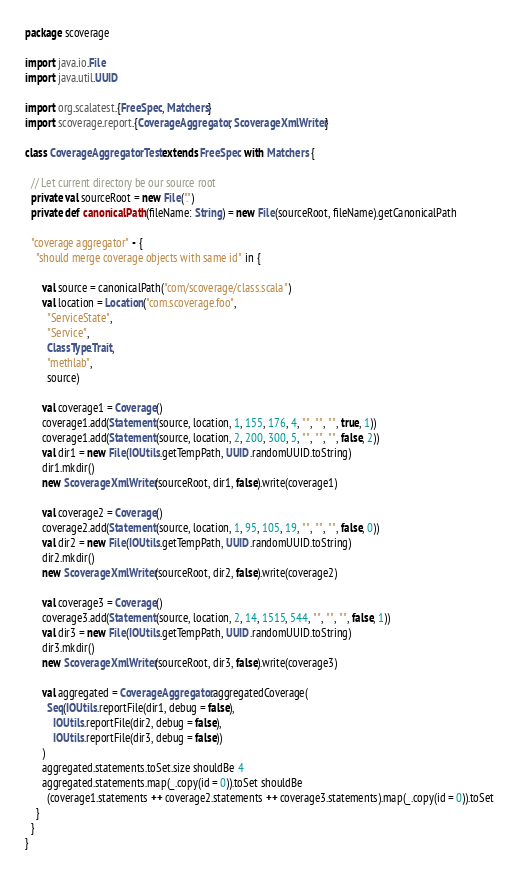Convert code to text. <code><loc_0><loc_0><loc_500><loc_500><_Scala_>package scoverage

import java.io.File
import java.util.UUID

import org.scalatest.{FreeSpec, Matchers}
import scoverage.report.{CoverageAggregator, ScoverageXmlWriter}

class CoverageAggregatorTest extends FreeSpec with Matchers {

  // Let current directory be our source root
  private val sourceRoot = new File(".")
  private def canonicalPath(fileName: String) = new File(sourceRoot, fileName).getCanonicalPath

  "coverage aggregator" - {
    "should merge coverage objects with same id" in {

      val source = canonicalPath("com/scoverage/class.scala")
      val location = Location("com.scoverage.foo",
        "ServiceState",
        "Service",
        ClassType.Trait,
        "methlab",
        source)

      val coverage1 = Coverage()
      coverage1.add(Statement(source, location, 1, 155, 176, 4, "", "", "", true, 1))
      coverage1.add(Statement(source, location, 2, 200, 300, 5, "", "", "", false, 2))
      val dir1 = new File(IOUtils.getTempPath, UUID.randomUUID.toString)
      dir1.mkdir()
      new ScoverageXmlWriter(sourceRoot, dir1, false).write(coverage1)

      val coverage2 = Coverage()
      coverage2.add(Statement(source, location, 1, 95, 105, 19, "", "", "", false, 0))
      val dir2 = new File(IOUtils.getTempPath, UUID.randomUUID.toString)
      dir2.mkdir()
      new ScoverageXmlWriter(sourceRoot, dir2, false).write(coverage2)

      val coverage3 = Coverage()
      coverage3.add(Statement(source, location, 2, 14, 1515, 544, "", "", "", false, 1))
      val dir3 = new File(IOUtils.getTempPath, UUID.randomUUID.toString)
      dir3.mkdir()
      new ScoverageXmlWriter(sourceRoot, dir3, false).write(coverage3)

      val aggregated = CoverageAggregator.aggregatedCoverage(
        Seq(IOUtils.reportFile(dir1, debug = false),
          IOUtils.reportFile(dir2, debug = false),
          IOUtils.reportFile(dir3, debug = false))
      )
      aggregated.statements.toSet.size shouldBe 4
      aggregated.statements.map(_.copy(id = 0)).toSet shouldBe
        (coverage1.statements ++ coverage2.statements ++ coverage3.statements).map(_.copy(id = 0)).toSet
    }
  }
}
</code> 